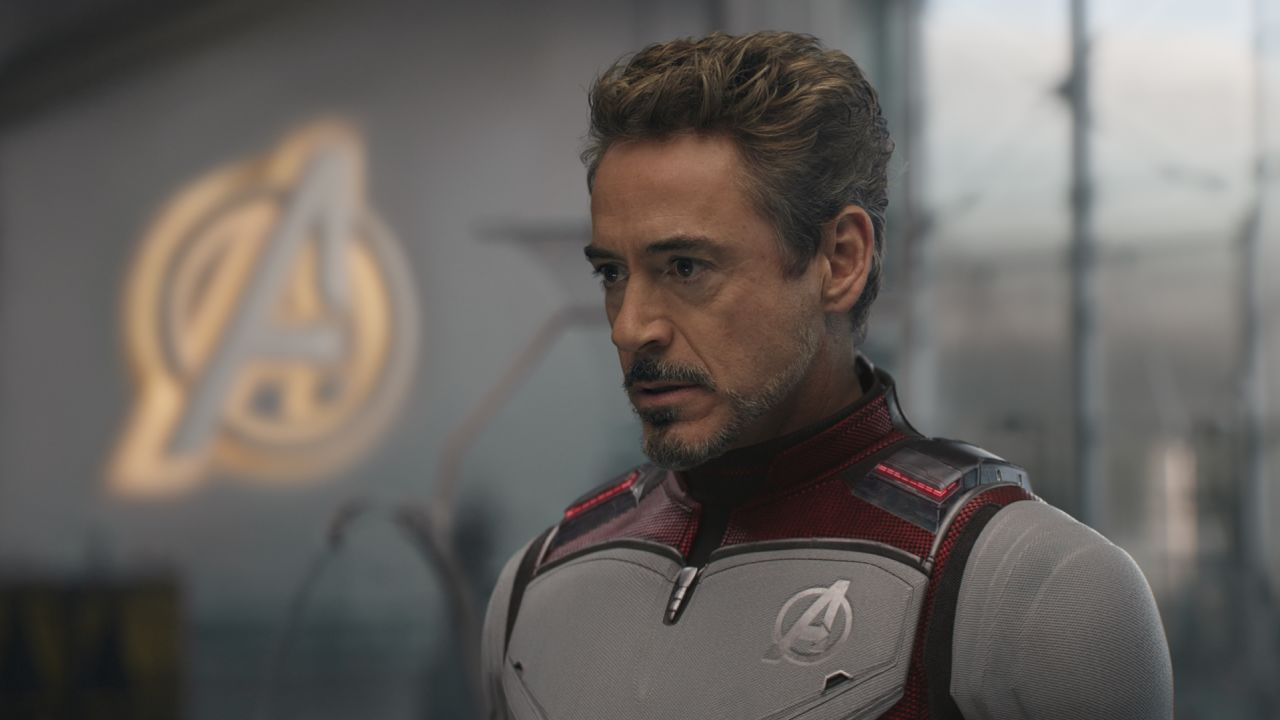Explain the significance of Tony Stark’s suit design in this image. The suit worn by Tony Stark in this image, enhanced with red and silver elements, symbolizes his alter ego, Iron Man, and reflects advanced technology and defense capabilities. The prominent display of the Avengers logo on his chest signifies his leadership and central role in the team, underscoring his commitment to their cause. 